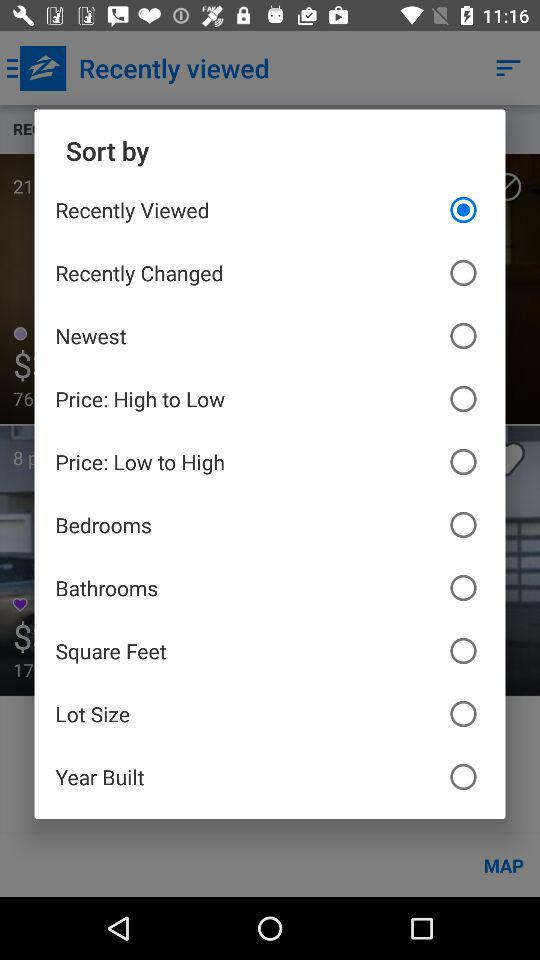Who is this application powered by?
When the provided information is insufficient, respond with <no answer>. <no answer> 